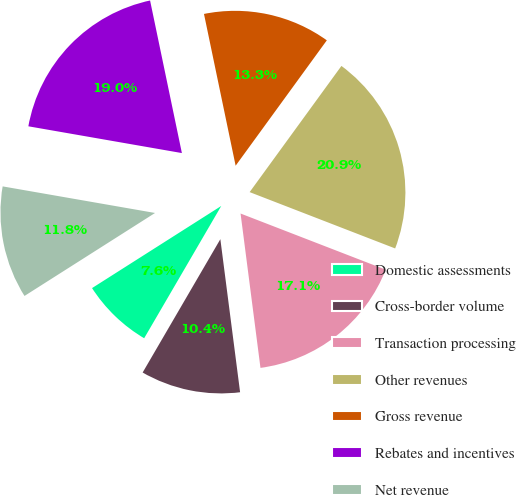<chart> <loc_0><loc_0><loc_500><loc_500><pie_chart><fcel>Domestic assessments<fcel>Cross-border volume<fcel>Transaction processing<fcel>Other revenues<fcel>Gross revenue<fcel>Rebates and incentives<fcel>Net revenue<nl><fcel>7.59%<fcel>10.44%<fcel>17.08%<fcel>20.87%<fcel>13.28%<fcel>18.98%<fcel>11.76%<nl></chart> 